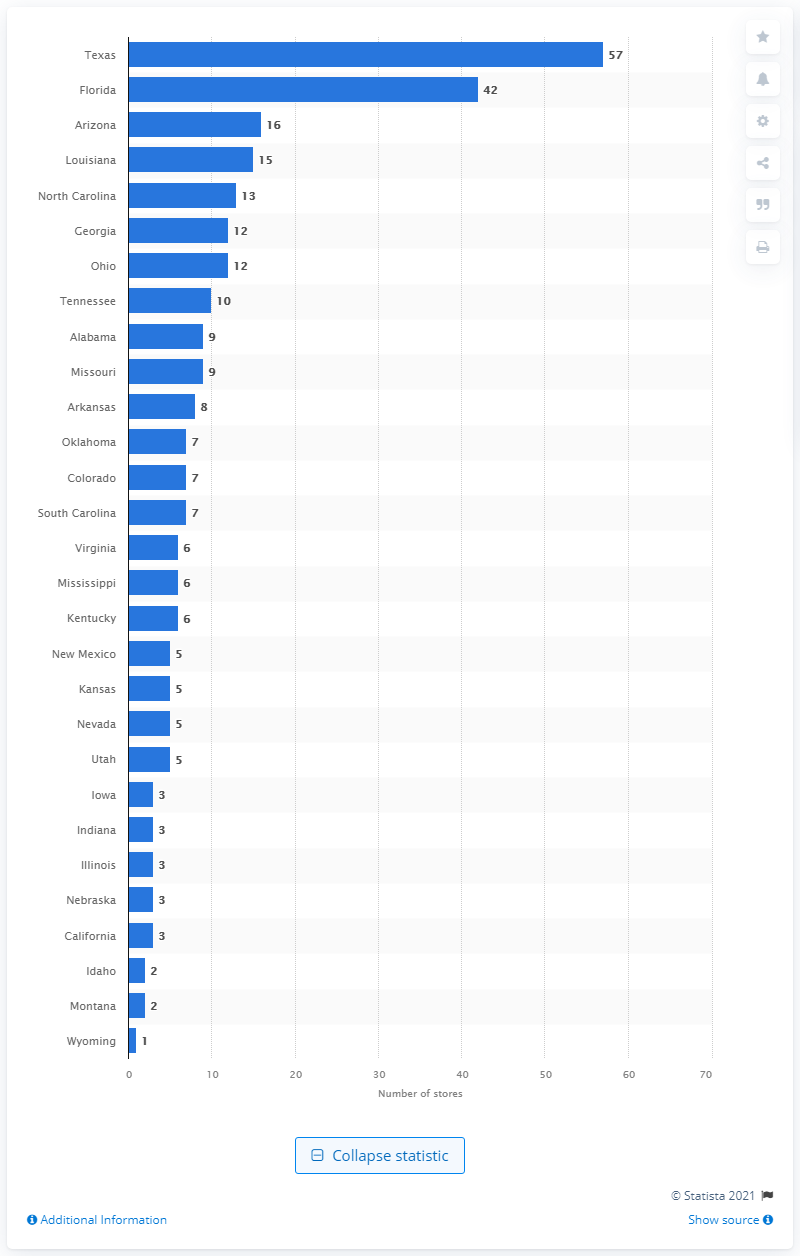Give some essential details in this illustration. Dillard's had 57 stores located in Texas. 